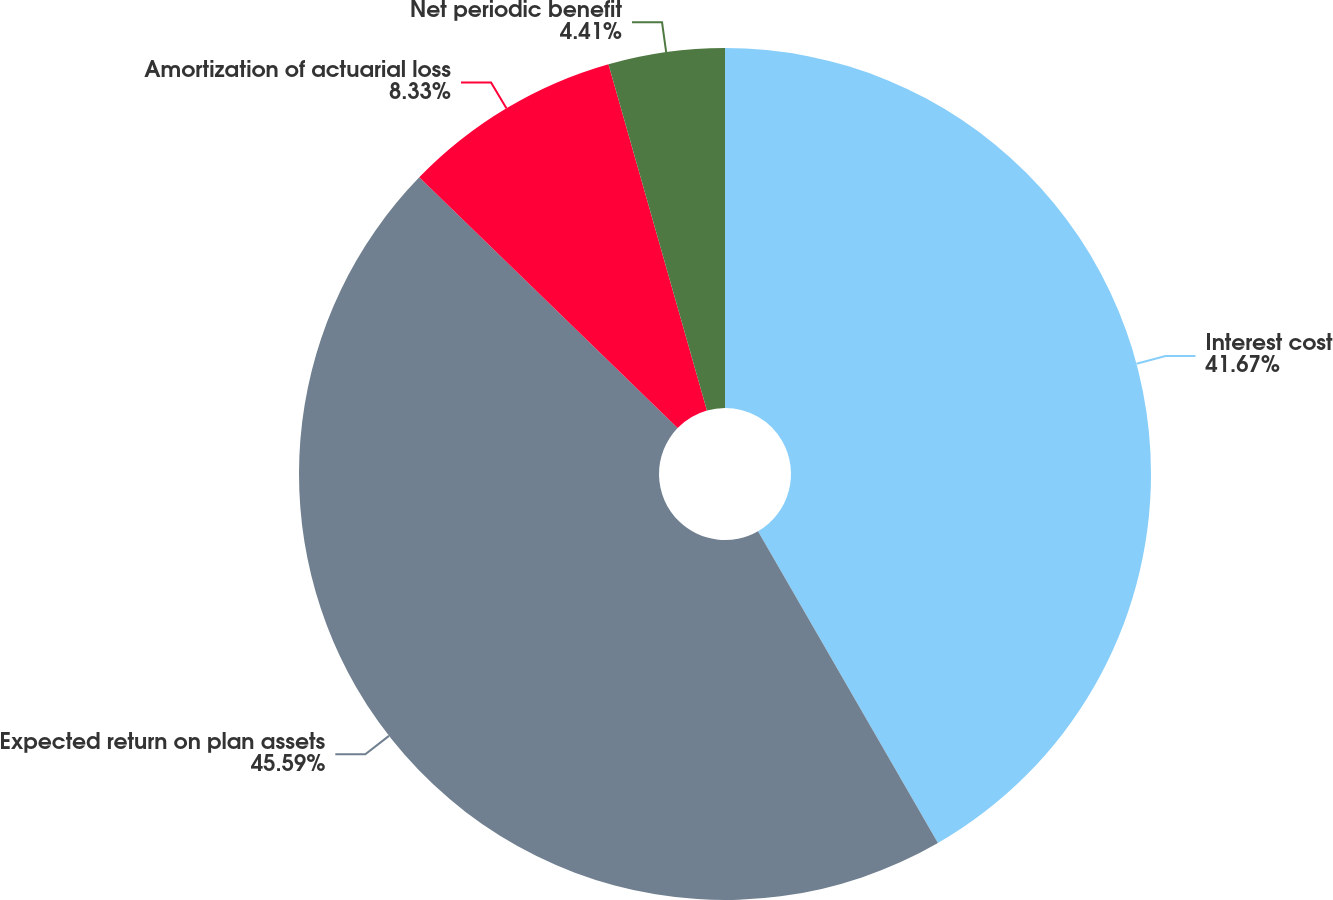Convert chart. <chart><loc_0><loc_0><loc_500><loc_500><pie_chart><fcel>Interest cost<fcel>Expected return on plan assets<fcel>Amortization of actuarial loss<fcel>Net periodic benefit<nl><fcel>41.67%<fcel>45.59%<fcel>8.33%<fcel>4.41%<nl></chart> 